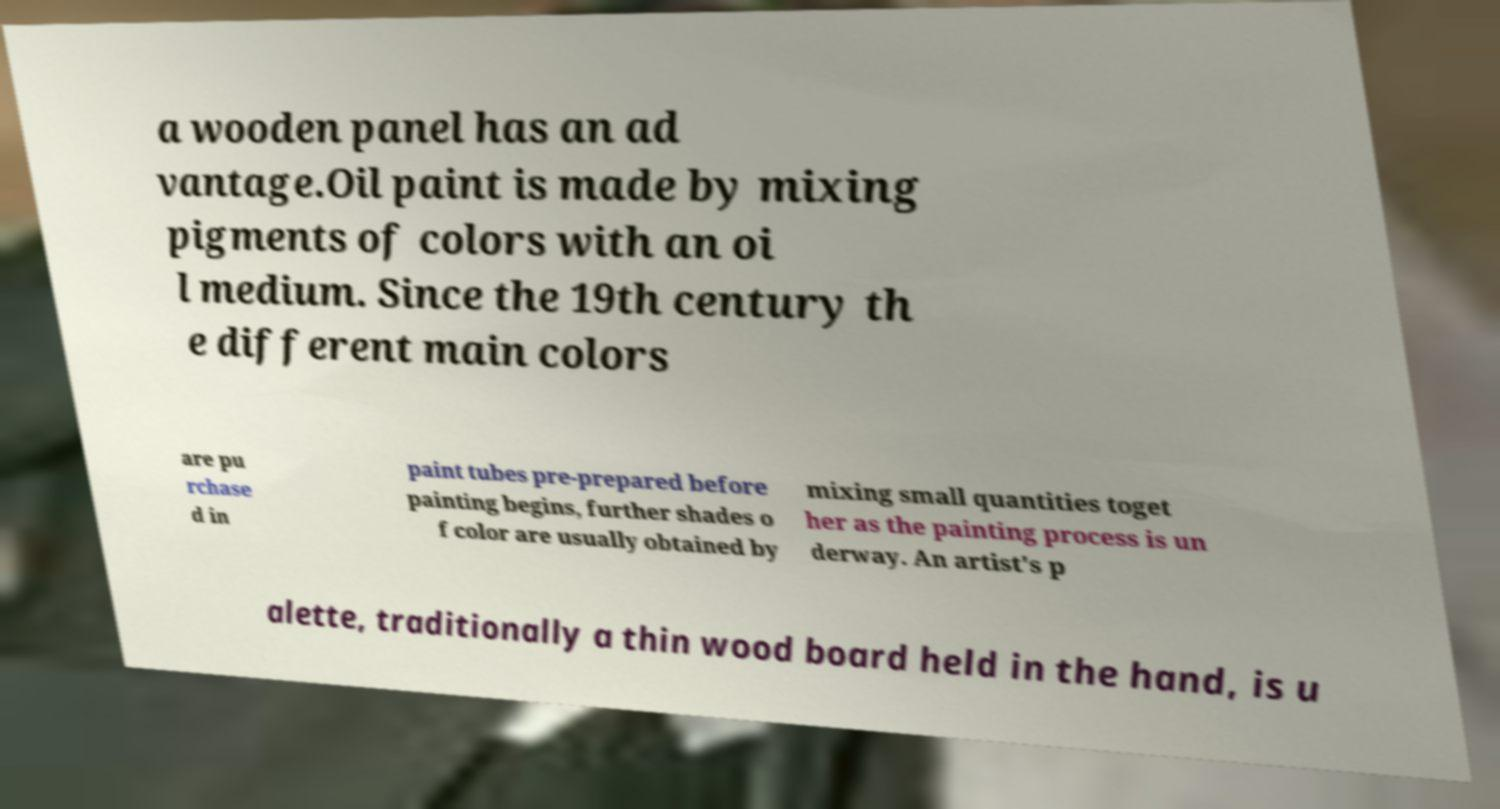Could you assist in decoding the text presented in this image and type it out clearly? a wooden panel has an ad vantage.Oil paint is made by mixing pigments of colors with an oi l medium. Since the 19th century th e different main colors are pu rchase d in paint tubes pre-prepared before painting begins, further shades o f color are usually obtained by mixing small quantities toget her as the painting process is un derway. An artist's p alette, traditionally a thin wood board held in the hand, is u 